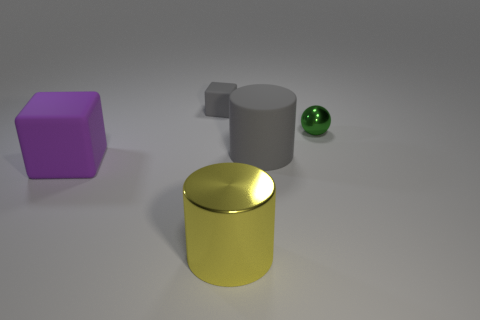There is a metallic thing that is behind the large yellow cylinder; what color is it?
Your answer should be compact. Green. There is a large object to the left of the yellow metallic object; are there any rubber cylinders behind it?
Provide a short and direct response. Yes. What number of other things are the same color as the small matte object?
Your answer should be very brief. 1. There is a rubber block that is in front of the small gray rubber block; is it the same size as the gray thing right of the tiny gray block?
Provide a succinct answer. Yes. What is the size of the matte block that is in front of the tiny thing on the left side of the yellow thing?
Keep it short and to the point. Large. There is a big thing that is both to the left of the matte cylinder and on the right side of the purple rubber thing; what is it made of?
Your answer should be compact. Metal. What is the color of the tiny metal ball?
Provide a succinct answer. Green. Is there any other thing that has the same material as the large gray cylinder?
Make the answer very short. Yes. What shape is the large object to the left of the yellow object?
Provide a succinct answer. Cube. There is a green metal object that is to the right of the gray object that is to the right of the tiny matte thing; are there any yellow metal objects that are in front of it?
Make the answer very short. Yes. 